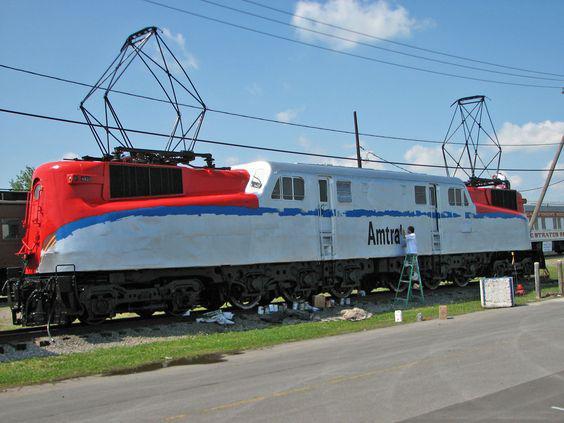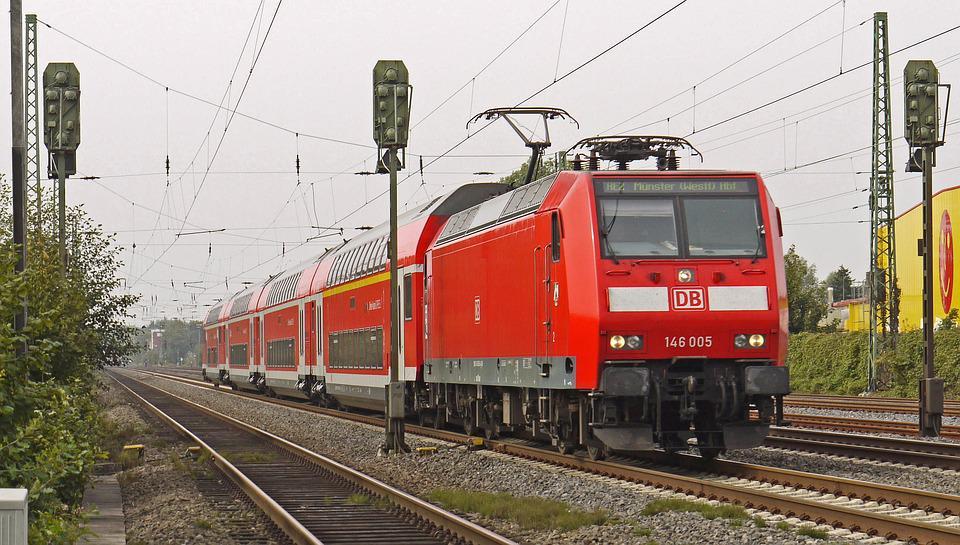The first image is the image on the left, the second image is the image on the right. Assess this claim about the two images: "There is exactly one power pole in the image on the left". Correct or not? Answer yes or no. Yes. The first image is the image on the left, the second image is the image on the right. For the images displayed, is the sentence "Trains in right and left images are true red and face different directions." factually correct? Answer yes or no. No. 